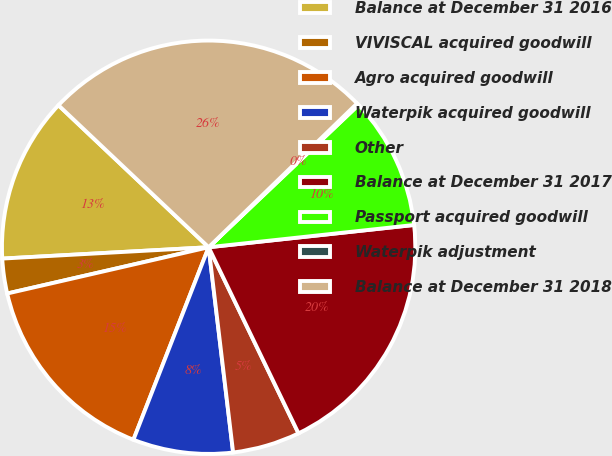Convert chart. <chart><loc_0><loc_0><loc_500><loc_500><pie_chart><fcel>Balance at December 31 2016<fcel>VIVISCAL acquired goodwill<fcel>Agro acquired goodwill<fcel>Waterpik acquired goodwill<fcel>Other<fcel>Balance at December 31 2017<fcel>Passport acquired goodwill<fcel>Waterpik adjustment<fcel>Balance at December 31 2018<nl><fcel>12.93%<fcel>2.72%<fcel>15.48%<fcel>7.82%<fcel>5.27%<fcel>19.56%<fcel>10.37%<fcel>0.16%<fcel>25.7%<nl></chart> 